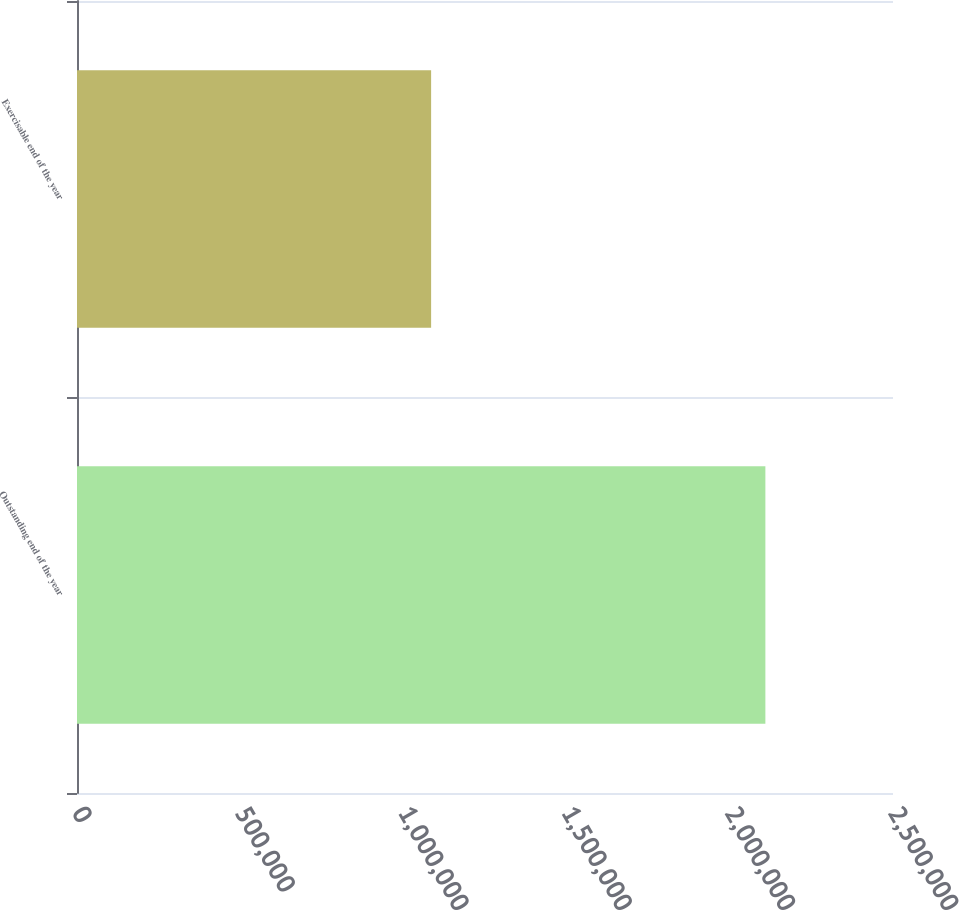Convert chart. <chart><loc_0><loc_0><loc_500><loc_500><bar_chart><fcel>Outstanding end of the year<fcel>Exercisable end of the year<nl><fcel>2.109e+06<fcel>1.08492e+06<nl></chart> 